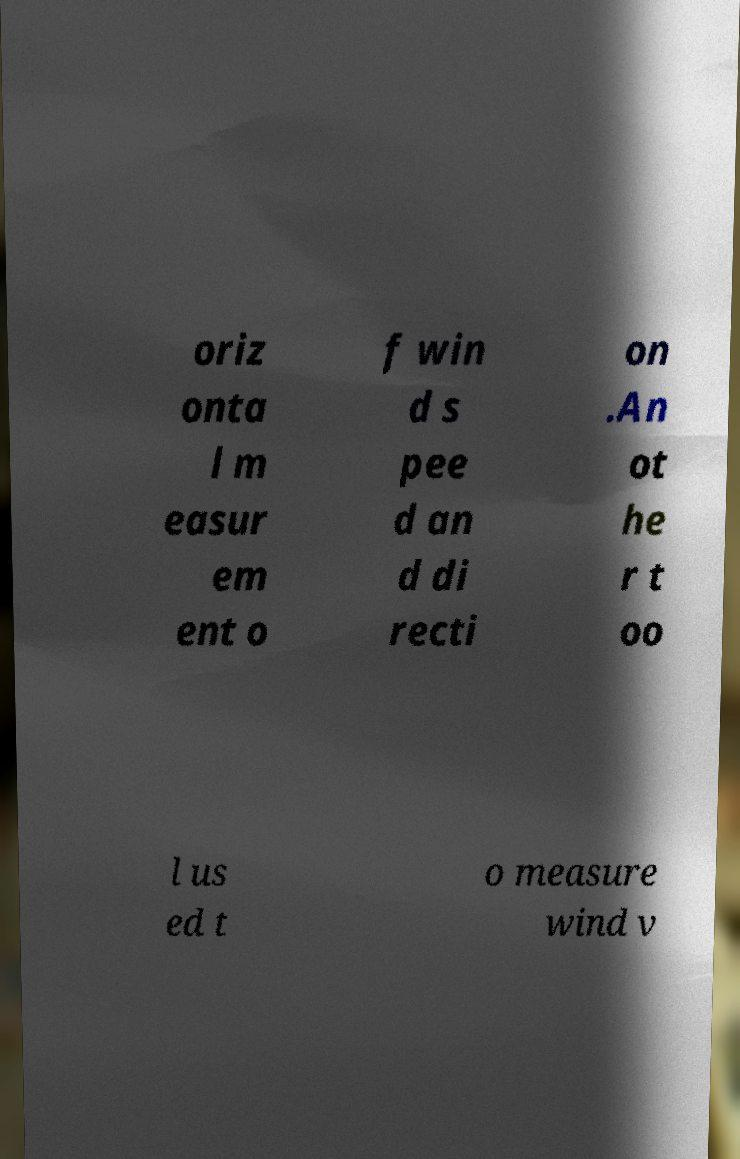Could you extract and type out the text from this image? oriz onta l m easur em ent o f win d s pee d an d di recti on .An ot he r t oo l us ed t o measure wind v 